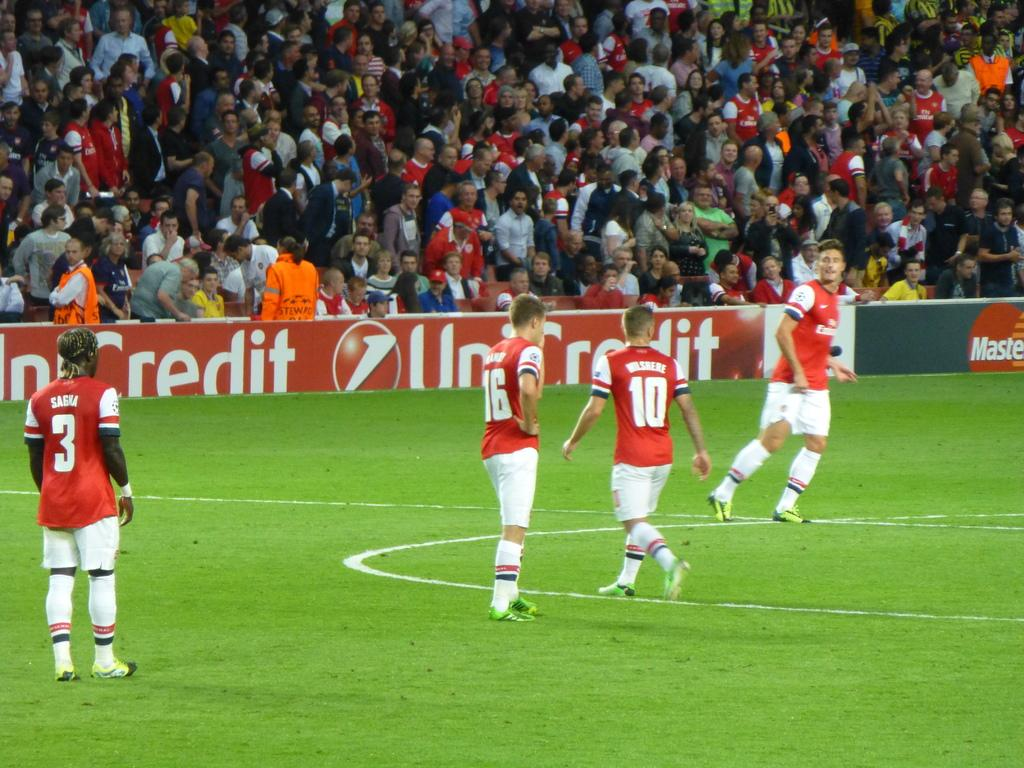<image>
Summarize the visual content of the image. Several young men are playing soccer, on a soccer field with a UniCredit banner in front of the stands. 